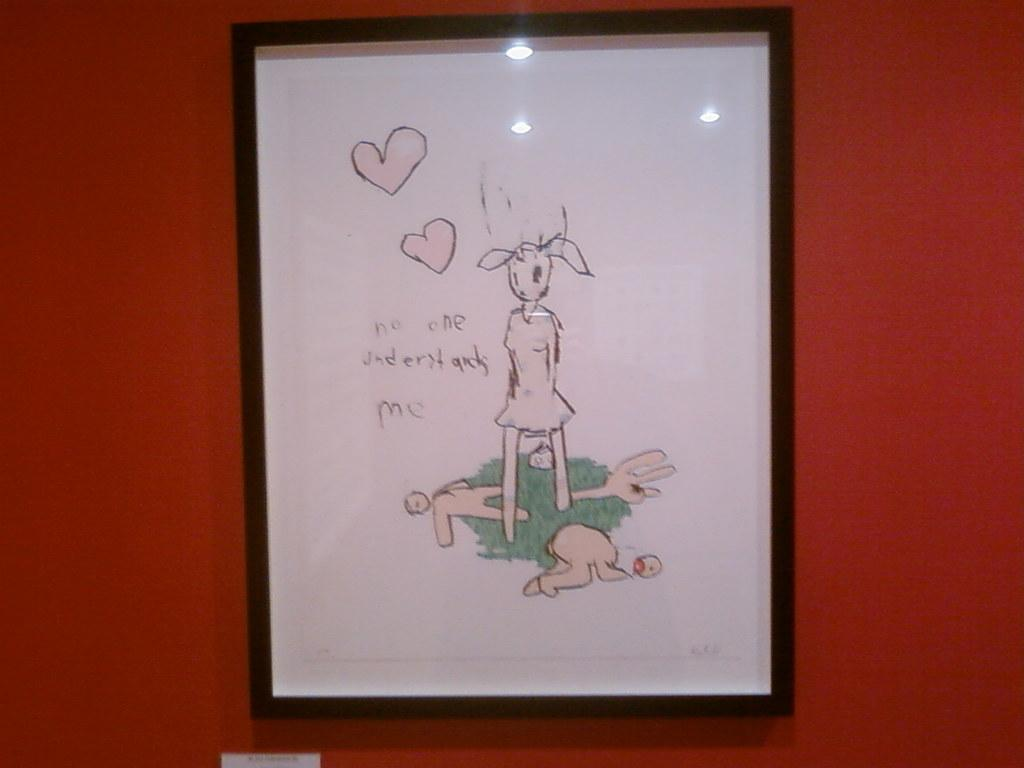Provide a one-sentence caption for the provided image. Portrait that says "Noone understands Me" with a rabbit holding a balloon. 